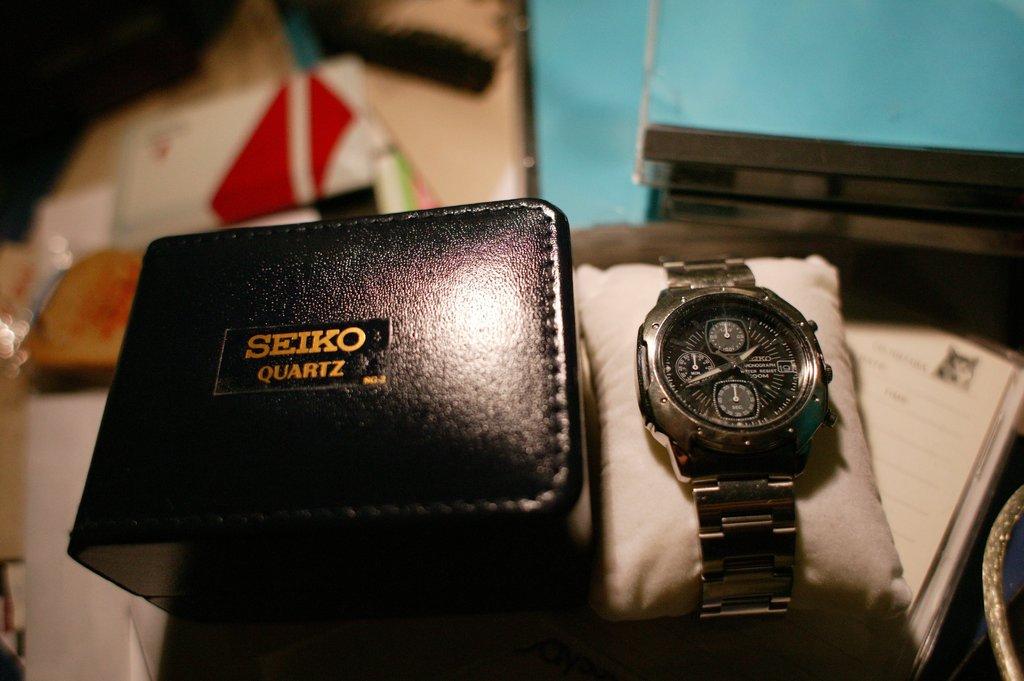What brand of watch is this?
Ensure brevity in your answer.  Seiko. Is this made of quartz?
Provide a short and direct response. Yes. 